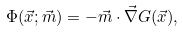<formula> <loc_0><loc_0><loc_500><loc_500>\Phi ( \vec { x } ; \vec { m } ) = - \vec { m } \cdot \vec { \nabla } G ( \vec { x } ) ,</formula> 